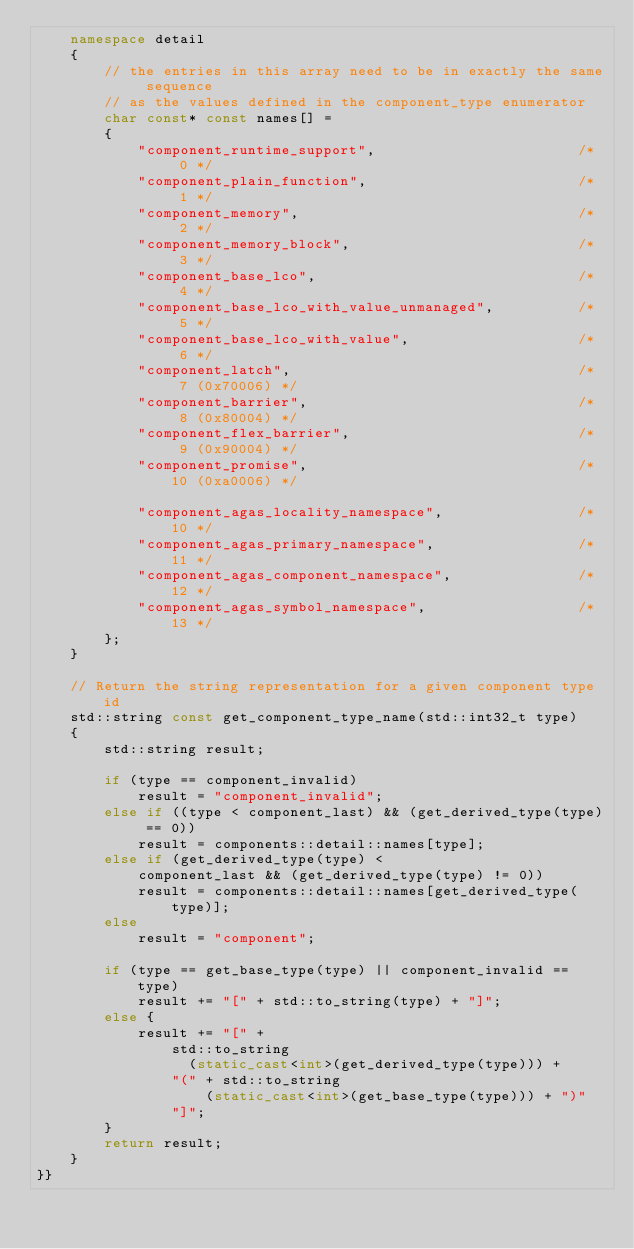Convert code to text. <code><loc_0><loc_0><loc_500><loc_500><_C++_>    namespace detail
    {
        // the entries in this array need to be in exactly the same sequence
        // as the values defined in the component_type enumerator
        char const* const names[] =
        {
            "component_runtime_support",                        /*  0 */
            "component_plain_function",                         /*  1 */
            "component_memory",                                 /*  2 */
            "component_memory_block",                           /*  3 */
            "component_base_lco",                               /*  4 */
            "component_base_lco_with_value_unmanaged",          /*  5 */
            "component_base_lco_with_value",                    /*  6 */
            "component_latch",                                  /*  7 (0x70006) */
            "component_barrier",                                /*  8 (0x80004) */
            "component_flex_barrier",                           /*  9 (0x90004) */
            "component_promise",                                /* 10 (0xa0006) */

            "component_agas_locality_namespace",                /* 10 */
            "component_agas_primary_namespace",                 /* 11 */
            "component_agas_component_namespace",               /* 12 */
            "component_agas_symbol_namespace",                  /* 13 */
        };
    }

    // Return the string representation for a given component type id
    std::string const get_component_type_name(std::int32_t type)
    {
        std::string result;

        if (type == component_invalid)
            result = "component_invalid";
        else if ((type < component_last) && (get_derived_type(type) == 0))
            result = components::detail::names[type];
        else if (get_derived_type(type) <
            component_last && (get_derived_type(type) != 0))
            result = components::detail::names[get_derived_type(type)];
        else
            result = "component";

        if (type == get_base_type(type) || component_invalid == type)
            result += "[" + std::to_string(type) + "]";
        else {
            result += "[" +
                std::to_string
                  (static_cast<int>(get_derived_type(type))) +
                "(" + std::to_string
                    (static_cast<int>(get_base_type(type))) + ")"
                "]";
        }
        return result;
    }
}}

</code> 